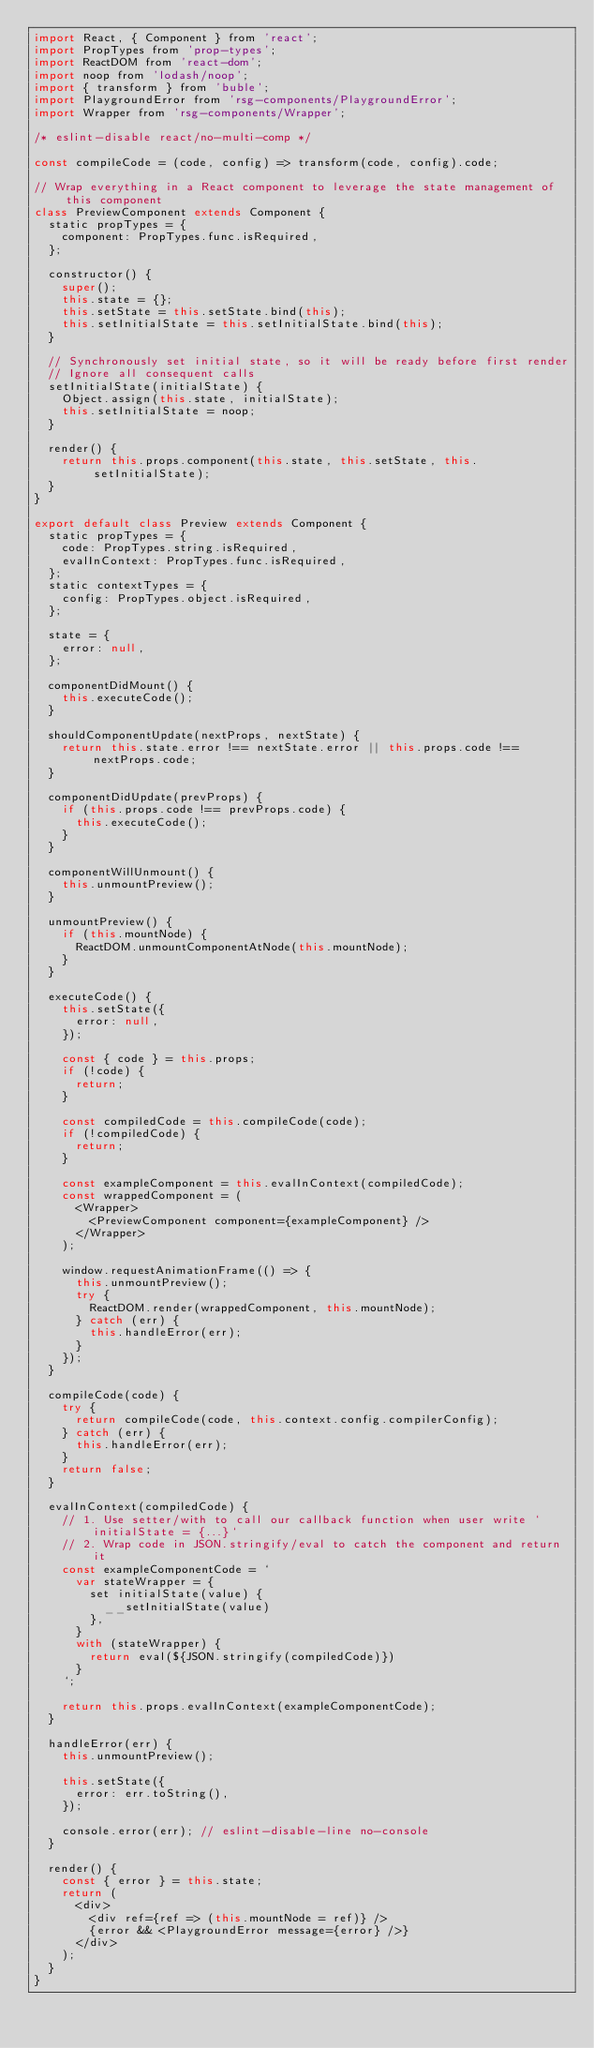<code> <loc_0><loc_0><loc_500><loc_500><_JavaScript_>import React, { Component } from 'react';
import PropTypes from 'prop-types';
import ReactDOM from 'react-dom';
import noop from 'lodash/noop';
import { transform } from 'buble';
import PlaygroundError from 'rsg-components/PlaygroundError';
import Wrapper from 'rsg-components/Wrapper';

/* eslint-disable react/no-multi-comp */

const compileCode = (code, config) => transform(code, config).code;

// Wrap everything in a React component to leverage the state management of this component
class PreviewComponent extends Component {
	static propTypes = {
		component: PropTypes.func.isRequired,
	};

	constructor() {
		super();
		this.state = {};
		this.setState = this.setState.bind(this);
		this.setInitialState = this.setInitialState.bind(this);
	}

	// Synchronously set initial state, so it will be ready before first render
	// Ignore all consequent calls
	setInitialState(initialState) {
		Object.assign(this.state, initialState);
		this.setInitialState = noop;
	}

	render() {
		return this.props.component(this.state, this.setState, this.setInitialState);
	}
}

export default class Preview extends Component {
	static propTypes = {
		code: PropTypes.string.isRequired,
		evalInContext: PropTypes.func.isRequired,
	};
	static contextTypes = {
		config: PropTypes.object.isRequired,
	};

	state = {
		error: null,
	};

	componentDidMount() {
		this.executeCode();
	}

	shouldComponentUpdate(nextProps, nextState) {
		return this.state.error !== nextState.error || this.props.code !== nextProps.code;
	}

	componentDidUpdate(prevProps) {
		if (this.props.code !== prevProps.code) {
			this.executeCode();
		}
	}

	componentWillUnmount() {
		this.unmountPreview();
	}

	unmountPreview() {
		if (this.mountNode) {
			ReactDOM.unmountComponentAtNode(this.mountNode);
		}
	}

	executeCode() {
		this.setState({
			error: null,
		});

		const { code } = this.props;
		if (!code) {
			return;
		}

		const compiledCode = this.compileCode(code);
		if (!compiledCode) {
			return;
		}

		const exampleComponent = this.evalInContext(compiledCode);
		const wrappedComponent = (
			<Wrapper>
				<PreviewComponent component={exampleComponent} />
			</Wrapper>
		);

		window.requestAnimationFrame(() => {
			this.unmountPreview();
			try {
				ReactDOM.render(wrappedComponent, this.mountNode);
			} catch (err) {
				this.handleError(err);
			}
		});
	}

	compileCode(code) {
		try {
			return compileCode(code, this.context.config.compilerConfig);
		} catch (err) {
			this.handleError(err);
		}
		return false;
	}

	evalInContext(compiledCode) {
		// 1. Use setter/with to call our callback function when user write `initialState = {...}`
		// 2. Wrap code in JSON.stringify/eval to catch the component and return it
		const exampleComponentCode = `
			var stateWrapper = {
				set initialState(value) {
					__setInitialState(value)
				},
			}
			with (stateWrapper) {
				return eval(${JSON.stringify(compiledCode)})
			}
		`;

		return this.props.evalInContext(exampleComponentCode);
	}

	handleError(err) {
		this.unmountPreview();

		this.setState({
			error: err.toString(),
		});

		console.error(err); // eslint-disable-line no-console
	}

	render() {
		const { error } = this.state;
		return (
			<div>
				<div ref={ref => (this.mountNode = ref)} />
				{error && <PlaygroundError message={error} />}
			</div>
		);
	}
}
</code> 